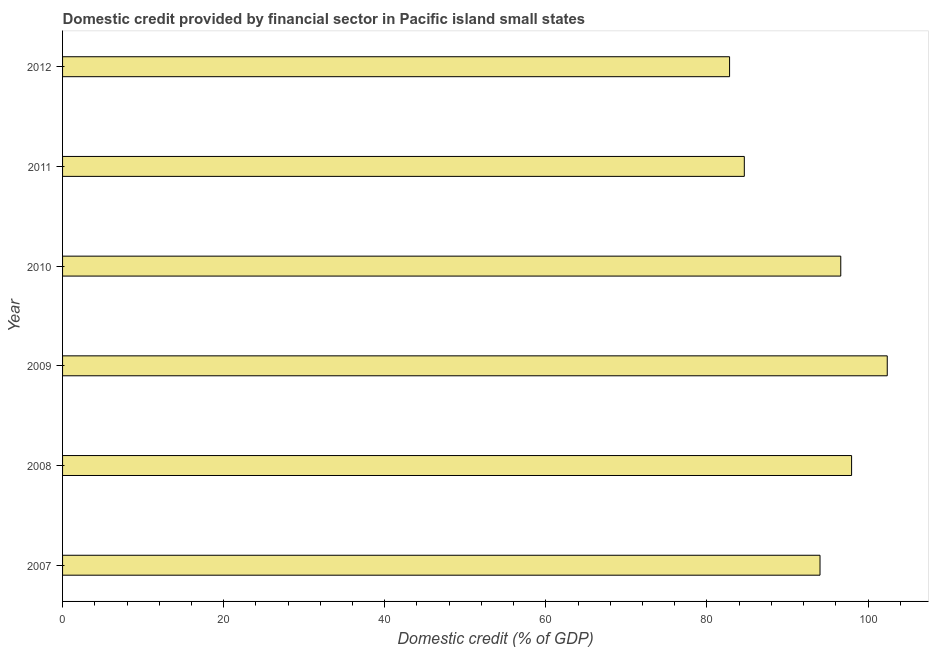Does the graph contain any zero values?
Keep it short and to the point. No. What is the title of the graph?
Keep it short and to the point. Domestic credit provided by financial sector in Pacific island small states. What is the label or title of the X-axis?
Make the answer very short. Domestic credit (% of GDP). What is the domestic credit provided by financial sector in 2008?
Keep it short and to the point. 97.96. Across all years, what is the maximum domestic credit provided by financial sector?
Offer a terse response. 102.39. Across all years, what is the minimum domestic credit provided by financial sector?
Make the answer very short. 82.81. In which year was the domestic credit provided by financial sector minimum?
Keep it short and to the point. 2012. What is the sum of the domestic credit provided by financial sector?
Offer a very short reply. 558.47. What is the difference between the domestic credit provided by financial sector in 2008 and 2009?
Your response must be concise. -4.43. What is the average domestic credit provided by financial sector per year?
Provide a short and direct response. 93.08. What is the median domestic credit provided by financial sector?
Make the answer very short. 95.33. What is the ratio of the domestic credit provided by financial sector in 2007 to that in 2011?
Offer a terse response. 1.11. What is the difference between the highest and the second highest domestic credit provided by financial sector?
Provide a short and direct response. 4.43. Is the sum of the domestic credit provided by financial sector in 2008 and 2012 greater than the maximum domestic credit provided by financial sector across all years?
Give a very brief answer. Yes. What is the difference between the highest and the lowest domestic credit provided by financial sector?
Your response must be concise. 19.58. In how many years, is the domestic credit provided by financial sector greater than the average domestic credit provided by financial sector taken over all years?
Provide a short and direct response. 4. How many years are there in the graph?
Give a very brief answer. 6. Are the values on the major ticks of X-axis written in scientific E-notation?
Your answer should be compact. No. What is the Domestic credit (% of GDP) of 2007?
Your answer should be very brief. 94.04. What is the Domestic credit (% of GDP) in 2008?
Offer a very short reply. 97.96. What is the Domestic credit (% of GDP) of 2009?
Give a very brief answer. 102.39. What is the Domestic credit (% of GDP) of 2010?
Keep it short and to the point. 96.62. What is the Domestic credit (% of GDP) of 2011?
Keep it short and to the point. 84.64. What is the Domestic credit (% of GDP) of 2012?
Offer a very short reply. 82.81. What is the difference between the Domestic credit (% of GDP) in 2007 and 2008?
Offer a terse response. -3.92. What is the difference between the Domestic credit (% of GDP) in 2007 and 2009?
Ensure brevity in your answer.  -8.35. What is the difference between the Domestic credit (% of GDP) in 2007 and 2010?
Keep it short and to the point. -2.58. What is the difference between the Domestic credit (% of GDP) in 2007 and 2011?
Make the answer very short. 9.4. What is the difference between the Domestic credit (% of GDP) in 2007 and 2012?
Your answer should be very brief. 11.23. What is the difference between the Domestic credit (% of GDP) in 2008 and 2009?
Your answer should be compact. -4.43. What is the difference between the Domestic credit (% of GDP) in 2008 and 2010?
Keep it short and to the point. 1.34. What is the difference between the Domestic credit (% of GDP) in 2008 and 2011?
Provide a succinct answer. 13.32. What is the difference between the Domestic credit (% of GDP) in 2008 and 2012?
Offer a terse response. 15.15. What is the difference between the Domestic credit (% of GDP) in 2009 and 2010?
Provide a succinct answer. 5.77. What is the difference between the Domestic credit (% of GDP) in 2009 and 2011?
Offer a very short reply. 17.75. What is the difference between the Domestic credit (% of GDP) in 2009 and 2012?
Make the answer very short. 19.58. What is the difference between the Domestic credit (% of GDP) in 2010 and 2011?
Offer a terse response. 11.98. What is the difference between the Domestic credit (% of GDP) in 2010 and 2012?
Ensure brevity in your answer.  13.8. What is the difference between the Domestic credit (% of GDP) in 2011 and 2012?
Your answer should be compact. 1.83. What is the ratio of the Domestic credit (% of GDP) in 2007 to that in 2009?
Offer a very short reply. 0.92. What is the ratio of the Domestic credit (% of GDP) in 2007 to that in 2011?
Give a very brief answer. 1.11. What is the ratio of the Domestic credit (% of GDP) in 2007 to that in 2012?
Offer a terse response. 1.14. What is the ratio of the Domestic credit (% of GDP) in 2008 to that in 2009?
Give a very brief answer. 0.96. What is the ratio of the Domestic credit (% of GDP) in 2008 to that in 2010?
Your response must be concise. 1.01. What is the ratio of the Domestic credit (% of GDP) in 2008 to that in 2011?
Provide a short and direct response. 1.16. What is the ratio of the Domestic credit (% of GDP) in 2008 to that in 2012?
Keep it short and to the point. 1.18. What is the ratio of the Domestic credit (% of GDP) in 2009 to that in 2010?
Provide a short and direct response. 1.06. What is the ratio of the Domestic credit (% of GDP) in 2009 to that in 2011?
Provide a short and direct response. 1.21. What is the ratio of the Domestic credit (% of GDP) in 2009 to that in 2012?
Your answer should be compact. 1.24. What is the ratio of the Domestic credit (% of GDP) in 2010 to that in 2011?
Offer a terse response. 1.14. What is the ratio of the Domestic credit (% of GDP) in 2010 to that in 2012?
Your response must be concise. 1.17. 